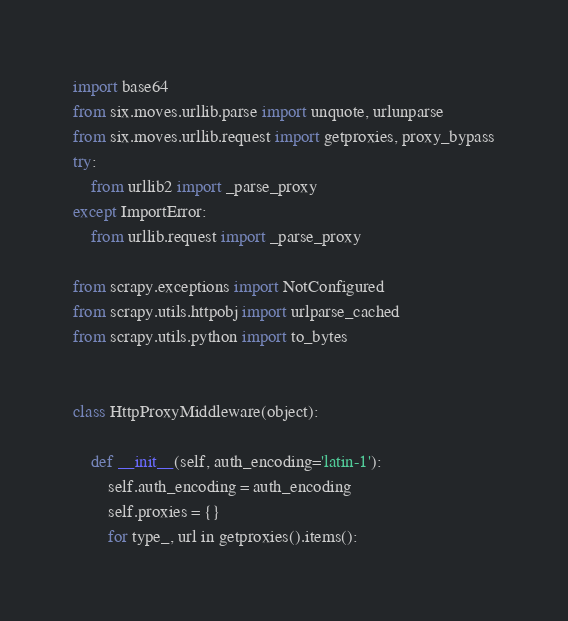Convert code to text. <code><loc_0><loc_0><loc_500><loc_500><_Python_>import base64
from six.moves.urllib.parse import unquote, urlunparse
from six.moves.urllib.request import getproxies, proxy_bypass
try:
    from urllib2 import _parse_proxy
except ImportError:
    from urllib.request import _parse_proxy

from scrapy.exceptions import NotConfigured
from scrapy.utils.httpobj import urlparse_cached
from scrapy.utils.python import to_bytes


class HttpProxyMiddleware(object):

    def __init__(self, auth_encoding='latin-1'):
        self.auth_encoding = auth_encoding
        self.proxies = {}
        for type_, url in getproxies().items():</code> 